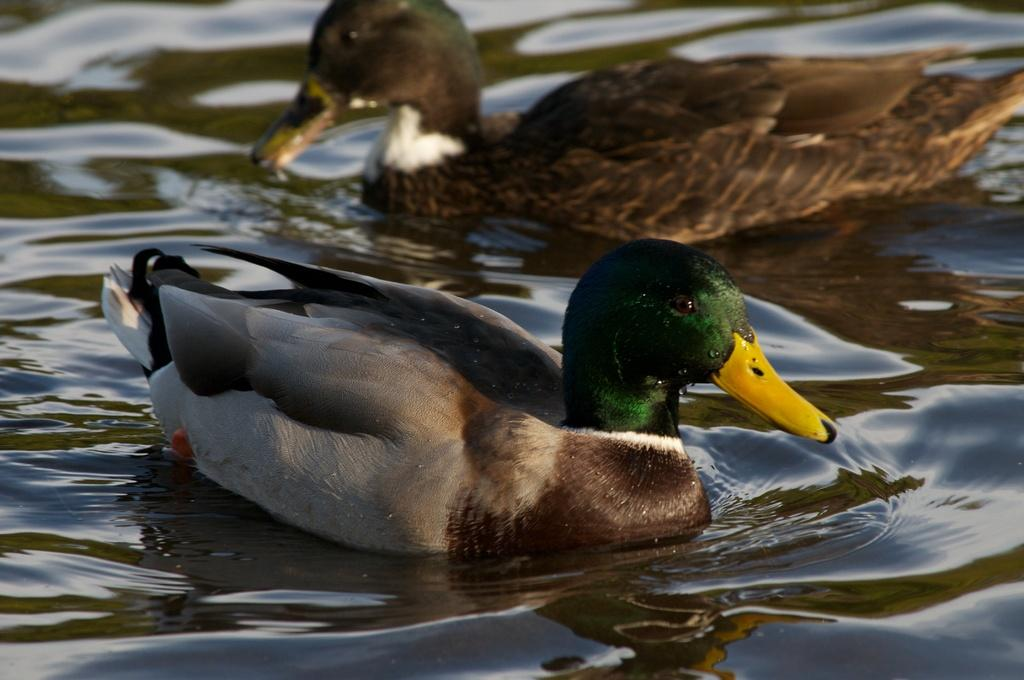What animals are present in the image? There are two birds in the image. Where are the birds located in the image? The birds are on the surface of water. What type of paste can be seen being applied to the donkey in the image? There is no donkey or paste present in the image; it features two birds on the surface of water. 